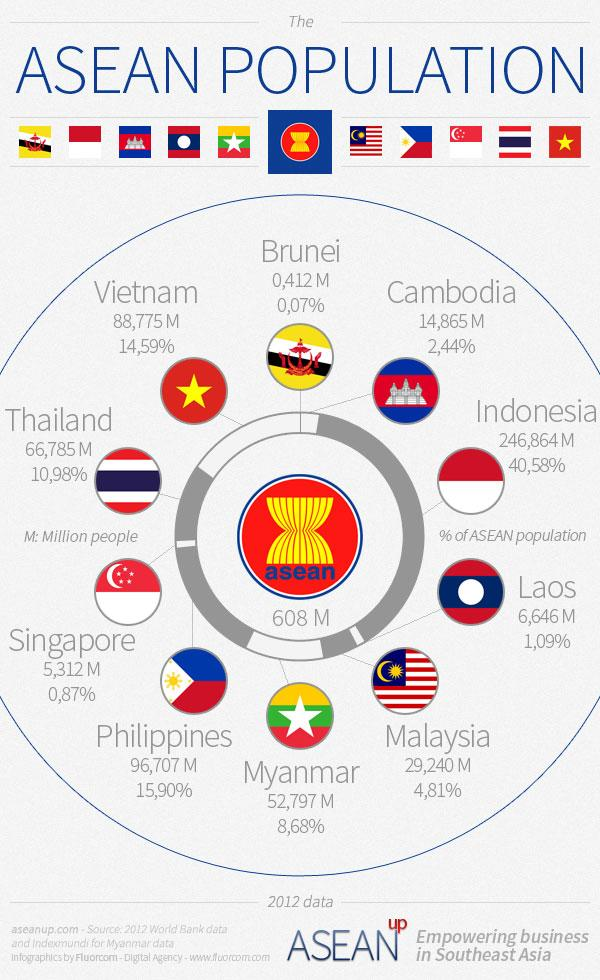Mention a couple of crucial points in this snapshot. The country with the largest percentage of the population in ASEAN is Indonesia, with 40.58% of the population. The Philippines has a population of 96,707 million people, making it the ASEAN country with the largest population. Thailand has the largest population among ASEAN countries, representing 10.98% of the region's overall population. Vietnam has a population of 88,775 million people, making it the ASEAN country with the largest population. According to available data, only two countries in the world have a population lower than 1% of the ASEAN population. 